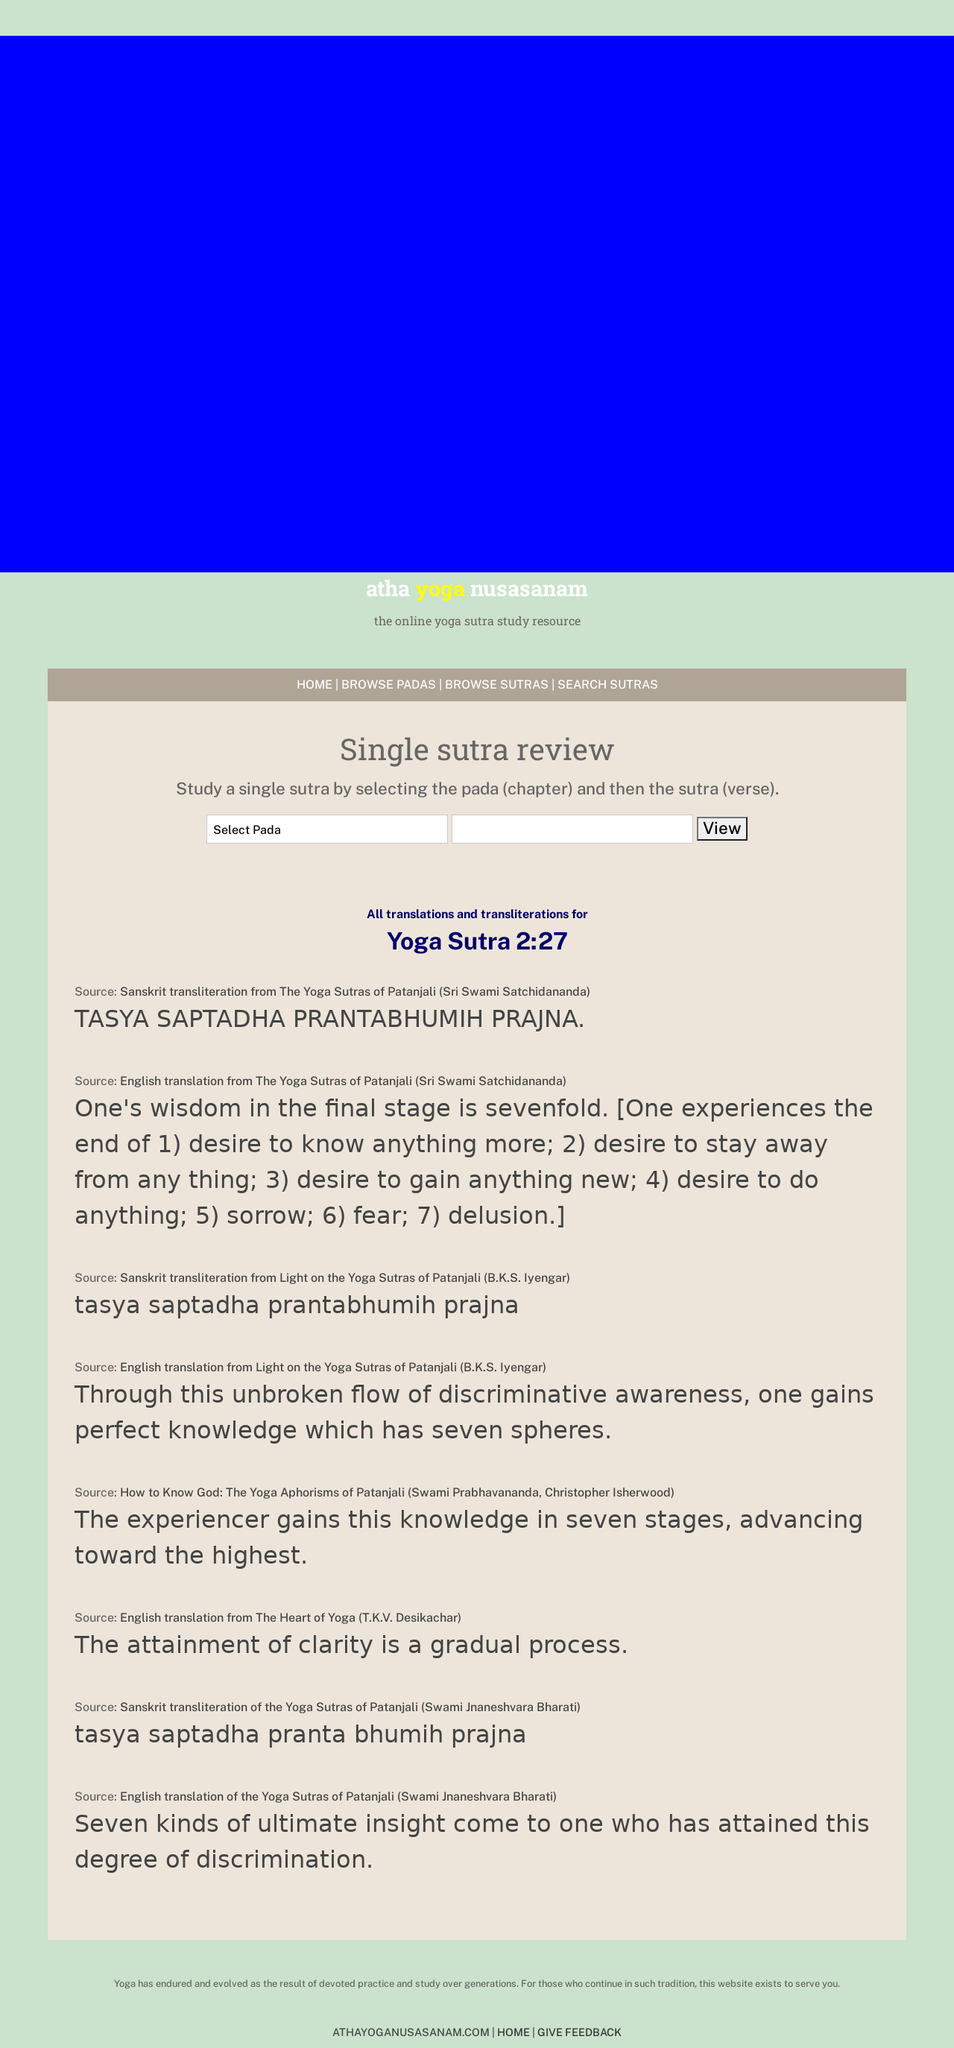What can you infer about the user experience on this website based on the layout and elements presented? The user experience on this website seems to be focused on simplicity and functionality. The layout is clean, with a well-organized structure that prioritizes easy navigation and accessibility of information. The use of dropdown menus for selecting sutras suggests an effort to make the search process straightforward. However, the text-heavy design and minimalistic use of color could be less engaging for some users. Overall, the website appears to provide a practical and user-friendly platform for studying yoga sutras, although enhancements in visual appeal might improve user engagement. 